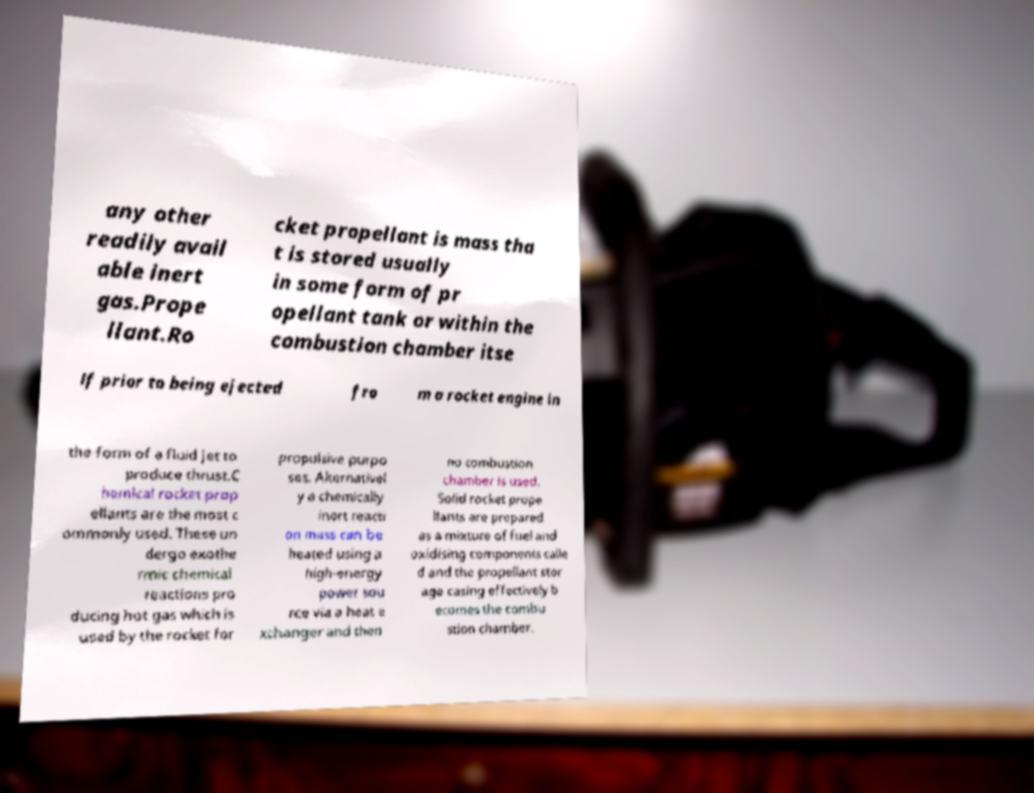What messages or text are displayed in this image? I need them in a readable, typed format. any other readily avail able inert gas.Prope llant.Ro cket propellant is mass tha t is stored usually in some form of pr opellant tank or within the combustion chamber itse lf prior to being ejected fro m a rocket engine in the form of a fluid jet to produce thrust.C hemical rocket prop ellants are the most c ommonly used. These un dergo exothe rmic chemical reactions pro ducing hot gas which is used by the rocket for propulsive purpo ses. Alternativel y a chemically inert reacti on mass can be heated using a high-energy power sou rce via a heat e xchanger and then no combustion chamber is used. Solid rocket prope llants are prepared as a mixture of fuel and oxidising components calle d and the propellant stor age casing effectively b ecomes the combu stion chamber. 